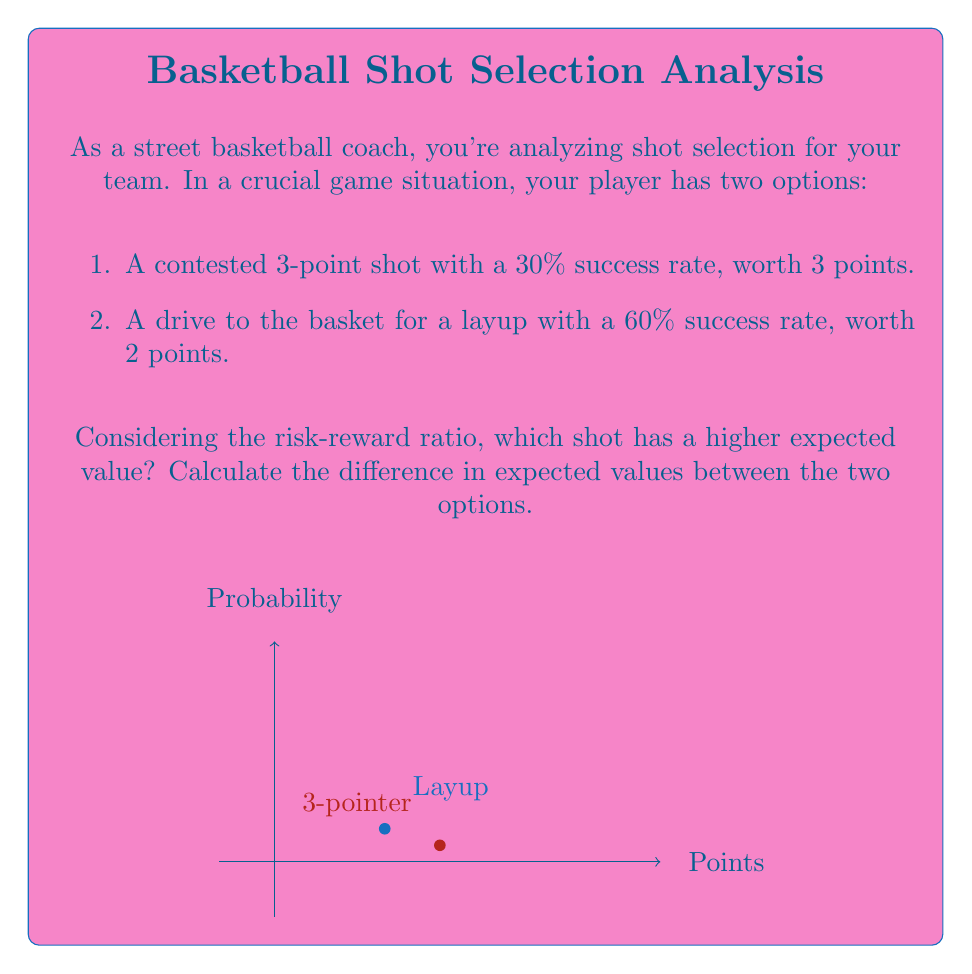Show me your answer to this math problem. Let's approach this step-by-step:

1) First, we need to calculate the expected value (EV) for each shot. The formula for expected value is:

   $EV = \text{Probability of Success} \times \text{Points Scored}$

2) For the 3-point shot:
   $EV_3 = 0.30 \times 3 = 0.90$ points

3) For the layup:
   $EV_2 = 0.60 \times 2 = 1.20$ points

4) To find which shot has a higher expected value, we compare:
   $EV_2 > EV_3$ (1.20 > 0.90)

5) To calculate the difference in expected values:
   $\text{Difference} = EV_2 - EV_3 = 1.20 - 0.90 = 0.30$ points

Therefore, the layup has a higher expected value, and the difference in expected values is 0.30 points.

This analysis shows that despite the lower point value, the higher probability of success for the layup makes it the better choice in terms of expected value. This demonstrates the importance of considering both risk (probability of success) and reward (points) in shot selection.
Answer: Layup; 0.30 points 